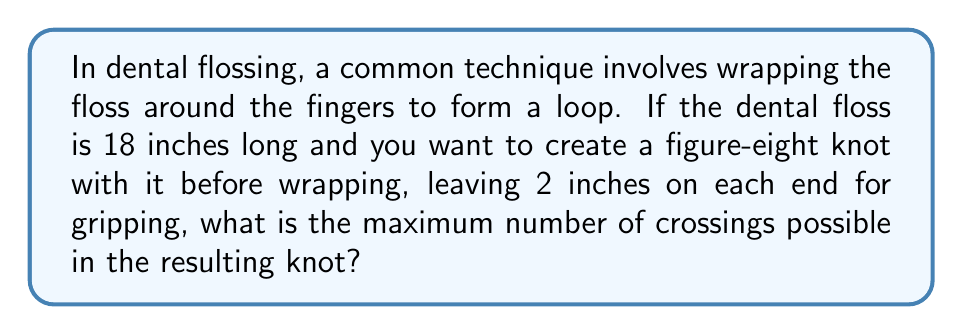Help me with this question. Let's approach this step-by-step:

1) First, we need to calculate the available length for the knot:
   Total length = 18 inches
   Gripping length = 2 inches × 2 = 4 inches
   Available length for knot = 18 - 4 = 14 inches

2) In knot theory, the crossing number of a knot is the smallest number of crossings in any diagram of the knot. However, we're asked for the maximum number of crossings possible.

3) The relationship between the length of rope (L) and the maximum number of crossings (C) is given by the inequality:

   $$ L \geq \frac{\pi}{2} \cdot C $$

4) Rearranging this inequality to solve for C:

   $$ C \leq \frac{2L}{\pi} $$

5) Substituting our available length of 14 inches:

   $$ C \leq \frac{2 \cdot 14}{\pi} \approx 8.917 $$

6) Since we're looking for the maximum number of crossings and C must be an integer, we round down to 8.

7) Therefore, the maximum number of crossings possible with 14 inches of dental floss is 8.

This result aligns with the practical aspects of dental flossing, as a knot with 8 crossings would still allow for effective cleaning while maintaining control of the floss.
Answer: 8 crossings 